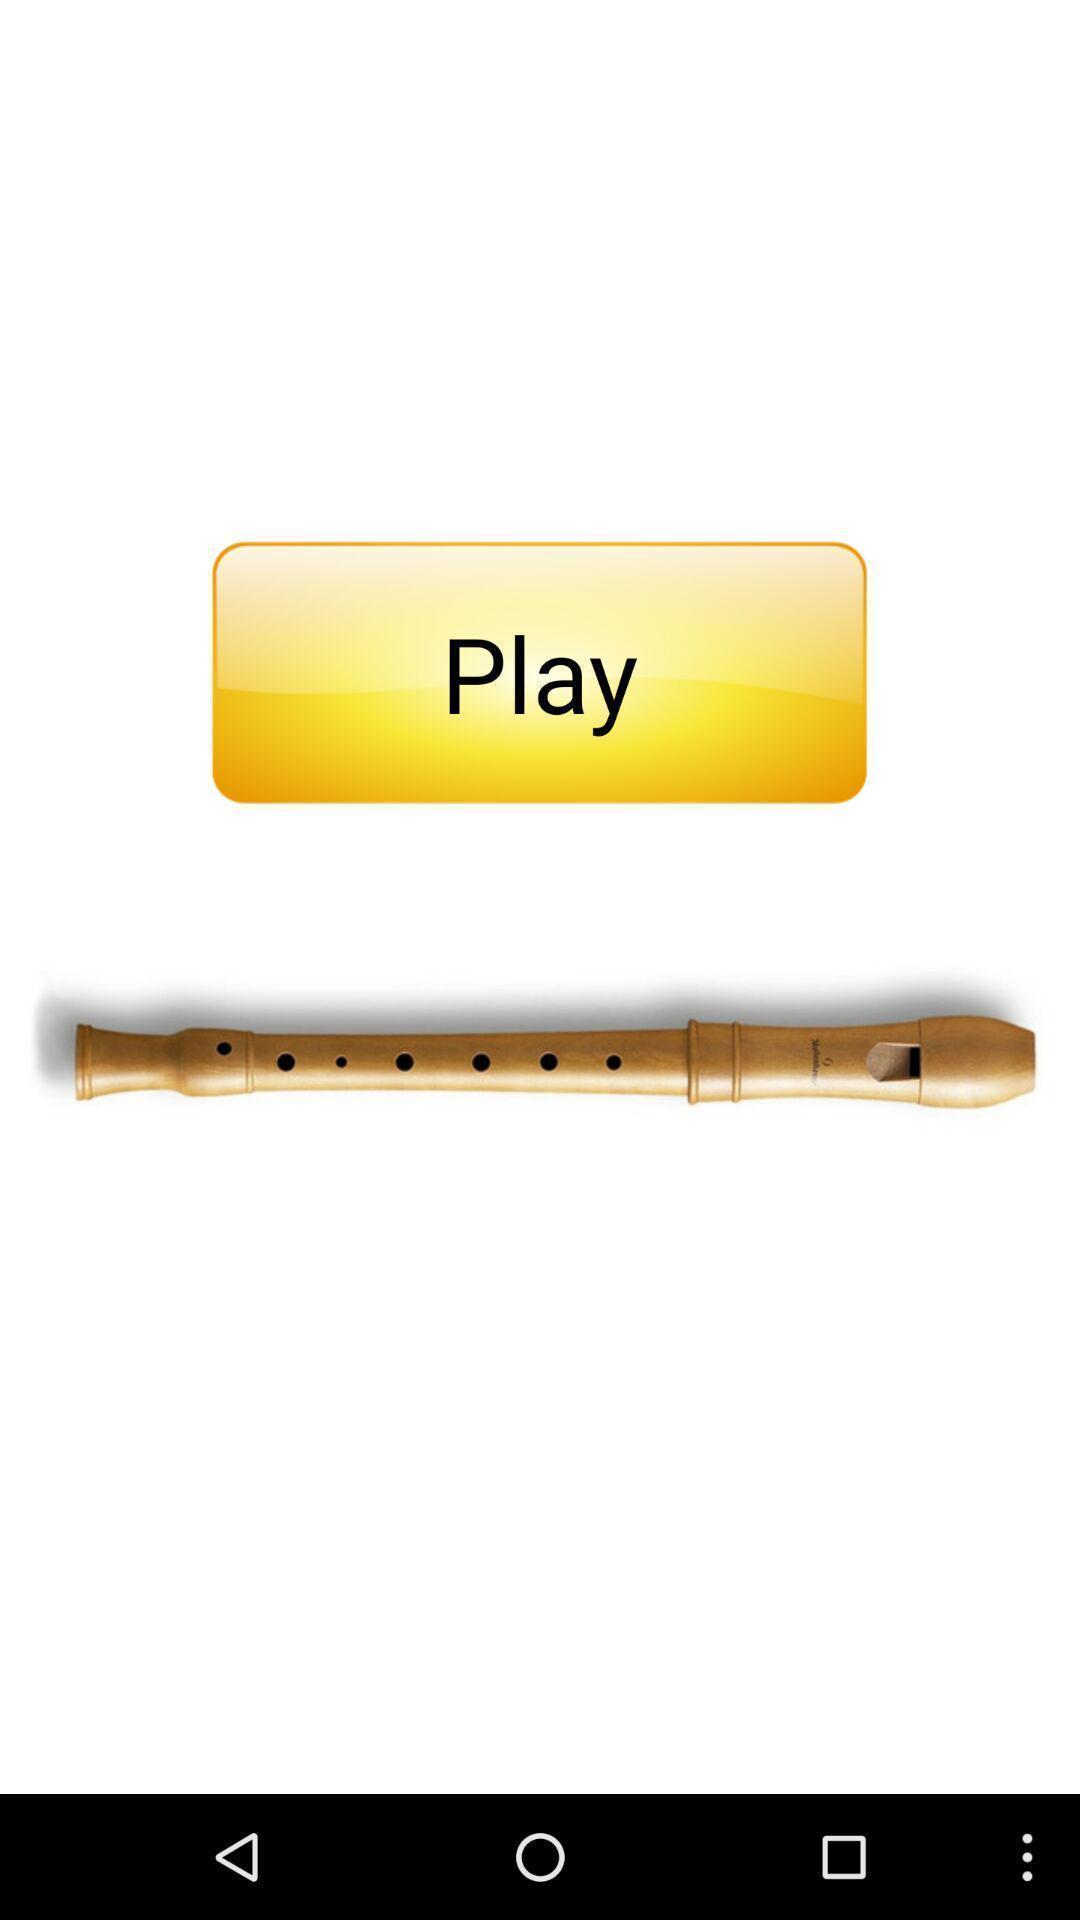Describe the content in this image. Play button is displaying to start using the app. 